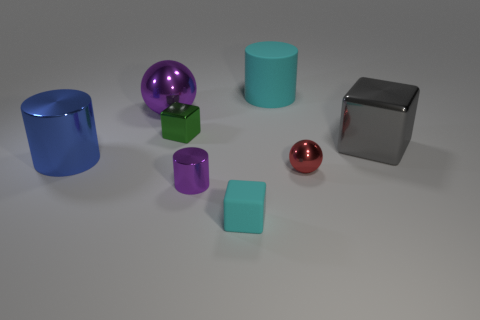Subtract all green metal cubes. How many cubes are left? 2 Subtract 1 spheres. How many spheres are left? 1 Add 1 metal objects. How many objects exist? 9 Subtract all red spheres. How many spheres are left? 1 Subtract all gray spheres. How many green cubes are left? 1 Subtract 1 cyan blocks. How many objects are left? 7 Subtract all spheres. How many objects are left? 6 Subtract all red cylinders. Subtract all red spheres. How many cylinders are left? 3 Subtract all tiny yellow rubber cylinders. Subtract all small cubes. How many objects are left? 6 Add 2 tiny shiny objects. How many tiny shiny objects are left? 5 